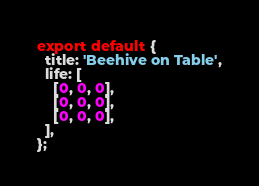Convert code to text. <code><loc_0><loc_0><loc_500><loc_500><_TypeScript_>export default {
  title: 'Beehive on Table',
  life: [
    [0, 0, 0],
    [0, 0, 0],
    [0, 0, 0],
  ],
};
</code> 